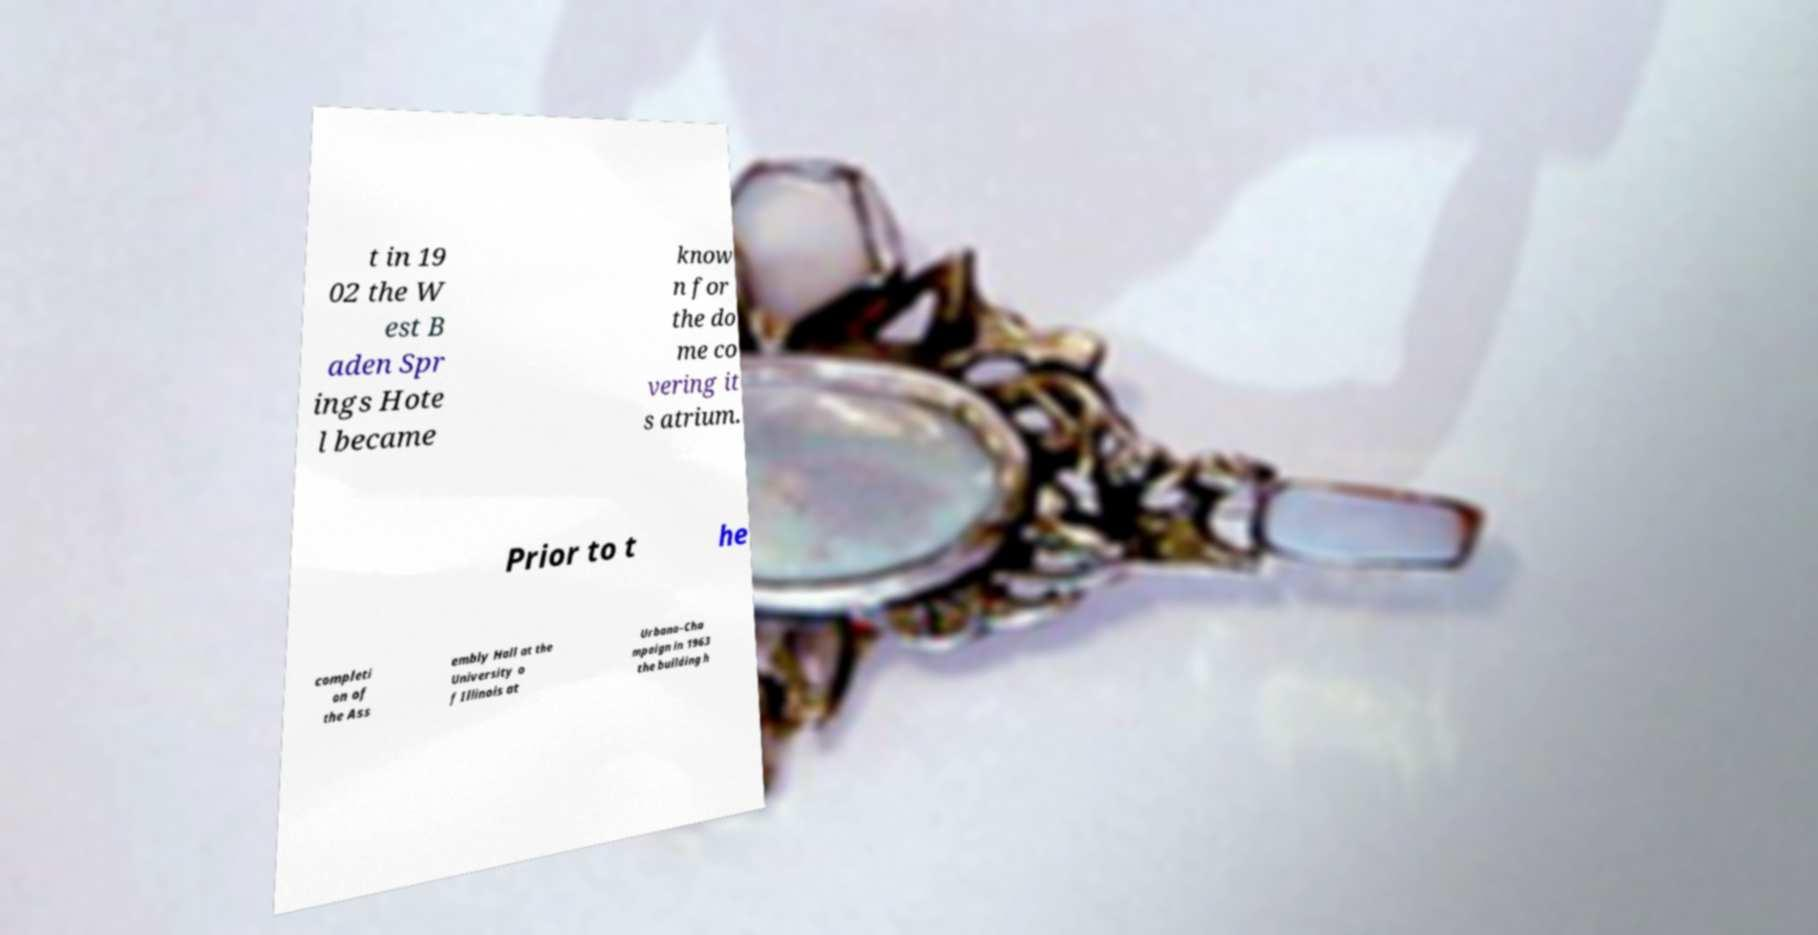Please identify and transcribe the text found in this image. t in 19 02 the W est B aden Spr ings Hote l became know n for the do me co vering it s atrium. Prior to t he completi on of the Ass embly Hall at the University o f Illinois at Urbana–Cha mpaign in 1963 the building h 